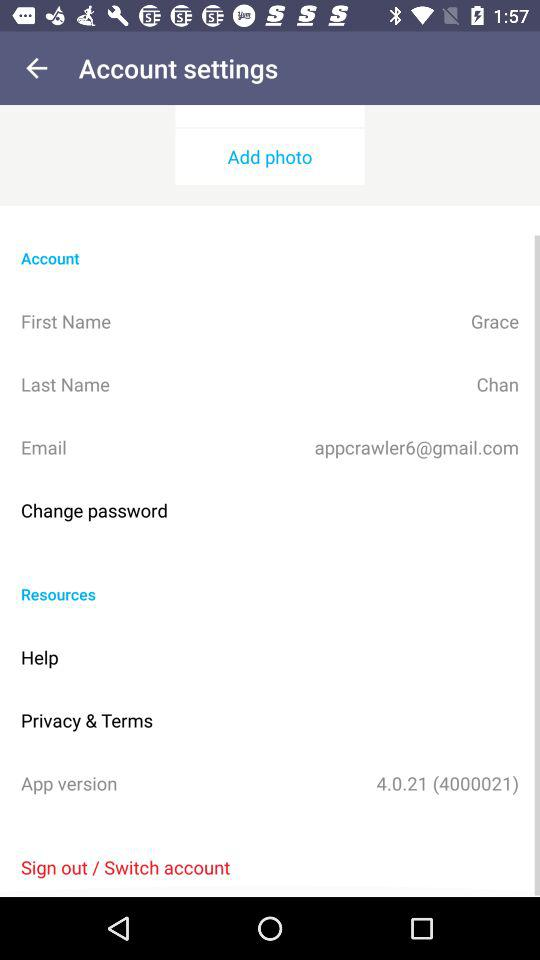What is the application version? The version of the application is 4.0.21 (4000021). 